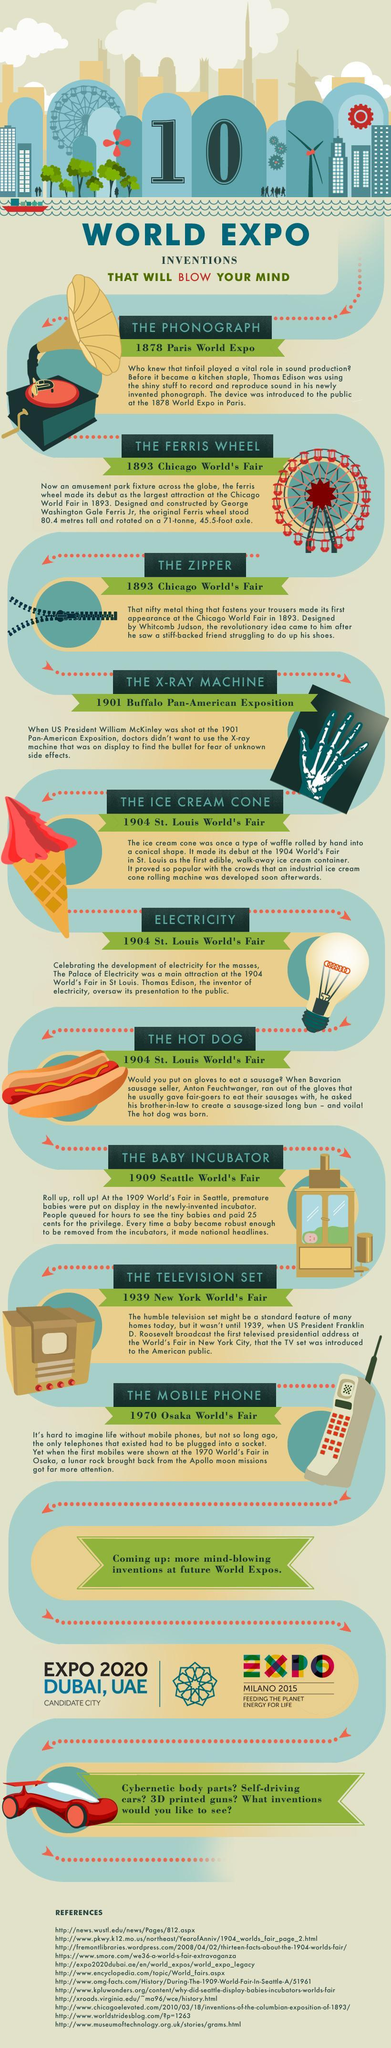What is the most common fixture found in most amusement parks across the globe?
Answer the question with a short phrase. The Ferris wheel Which invention was introduced at Buffalo Pan-American exposition? The X-ray machine Who invented the zipper and which year was it invented? Whitcomb Judson, 1893 Which two inventions of Thomas Edison where introduced at world expos? The phonograph, Electricity Which invention was introduced at the 1970 Osaka world's fair? The mobile phone What were the three inventions introduced at the 1904 Saint Louis world's fair? Ice cream cone, electricity, hot dog What did Thomas Edison invent in 1878? The phonograph What was the fee charged to view the infants in the incubator? 25 cents 